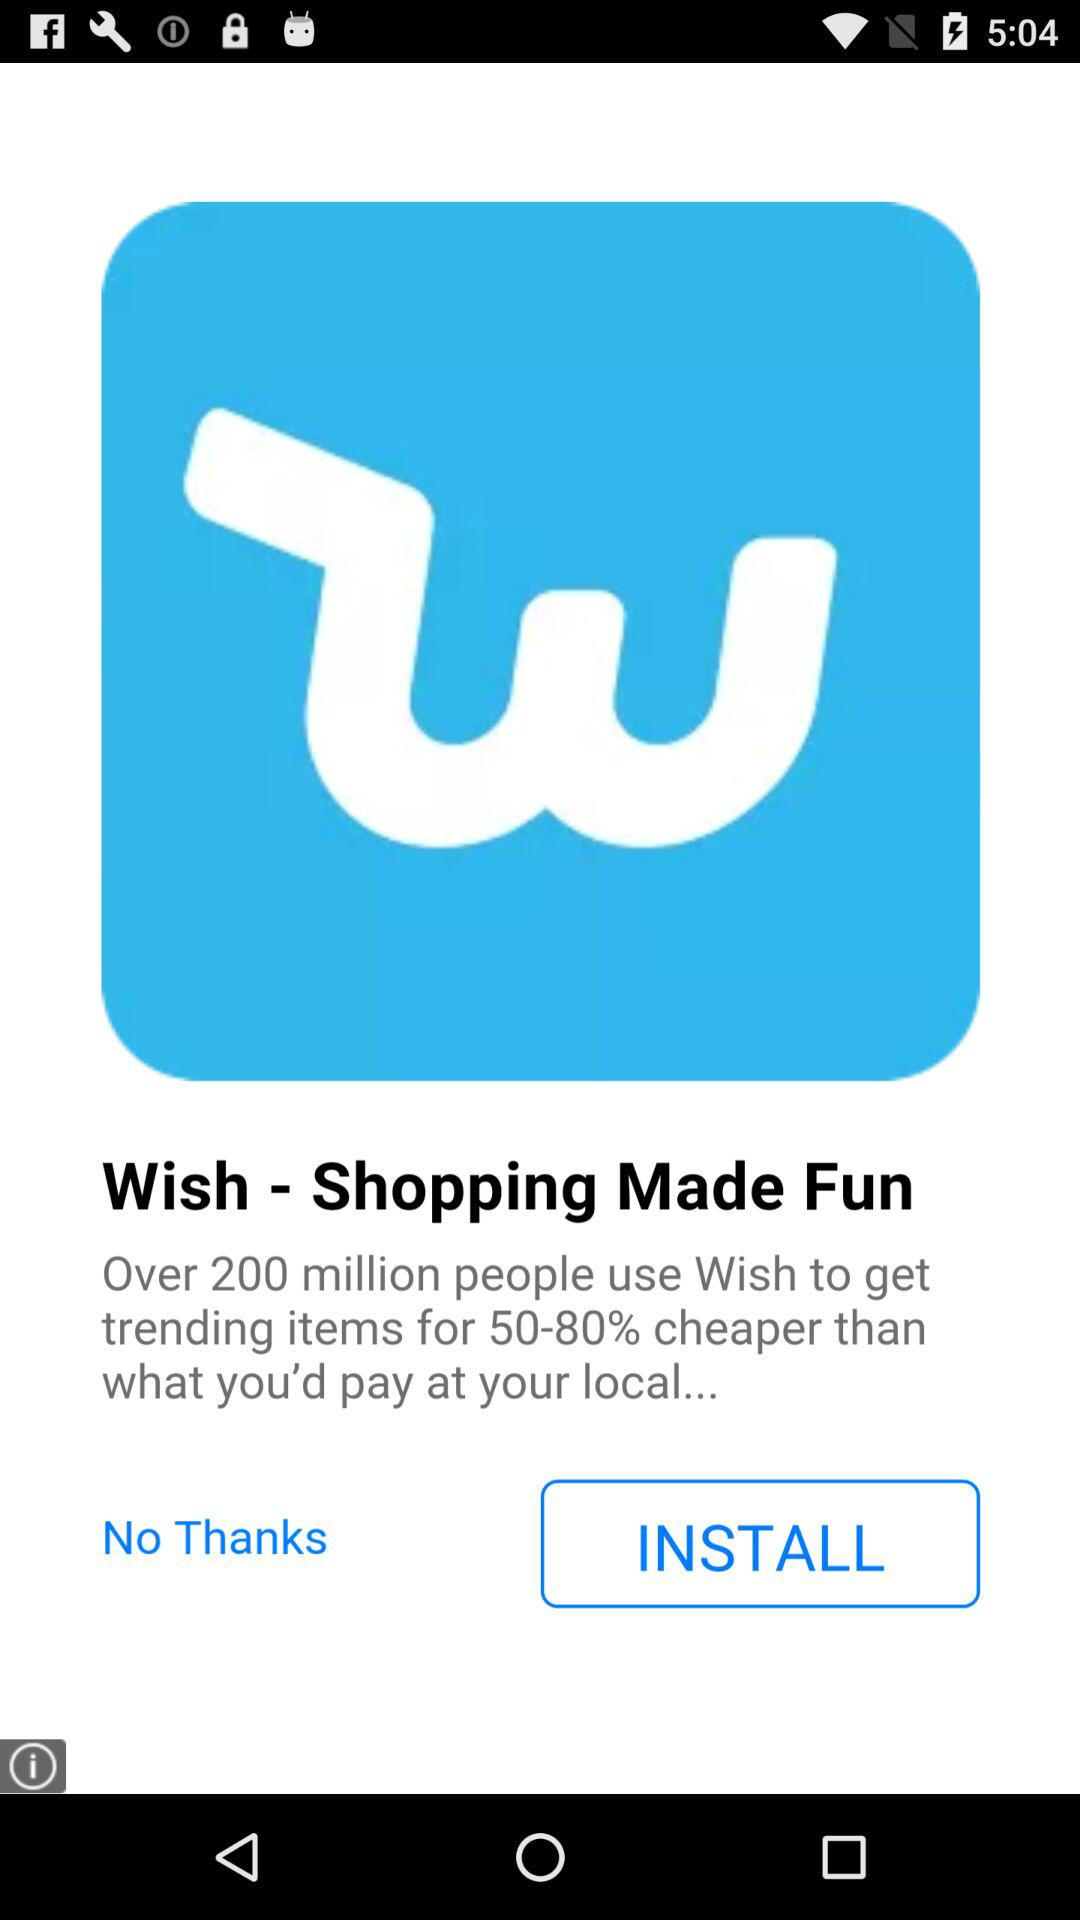What percentage of a discount do users get on "Wish"? Users get 50–80% of a discount on "Wish". 